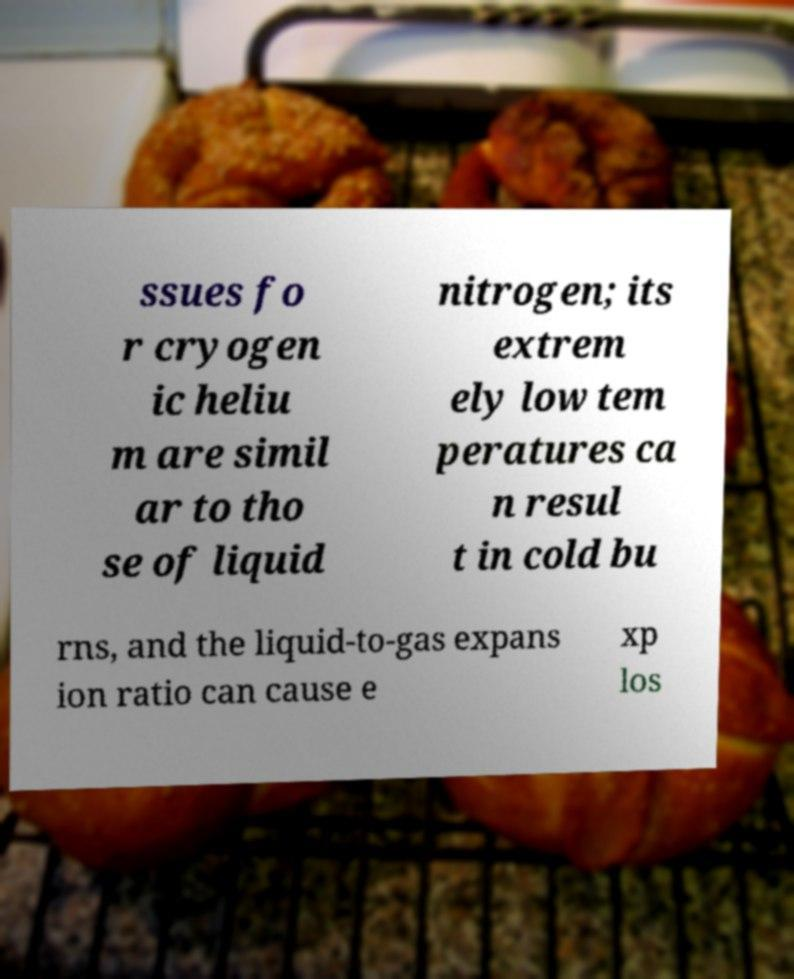Can you read and provide the text displayed in the image?This photo seems to have some interesting text. Can you extract and type it out for me? ssues fo r cryogen ic heliu m are simil ar to tho se of liquid nitrogen; its extrem ely low tem peratures ca n resul t in cold bu rns, and the liquid-to-gas expans ion ratio can cause e xp los 